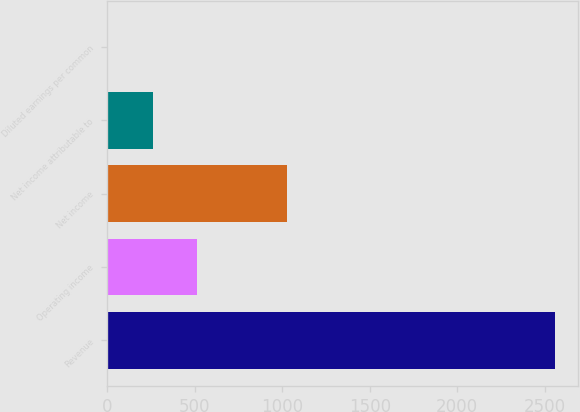Convert chart. <chart><loc_0><loc_0><loc_500><loc_500><bar_chart><fcel>Revenue<fcel>Operating income<fcel>Net income<fcel>Net income attributable to<fcel>Diluted earnings per common<nl><fcel>2560<fcel>513.58<fcel>1025.18<fcel>257.78<fcel>1.98<nl></chart> 